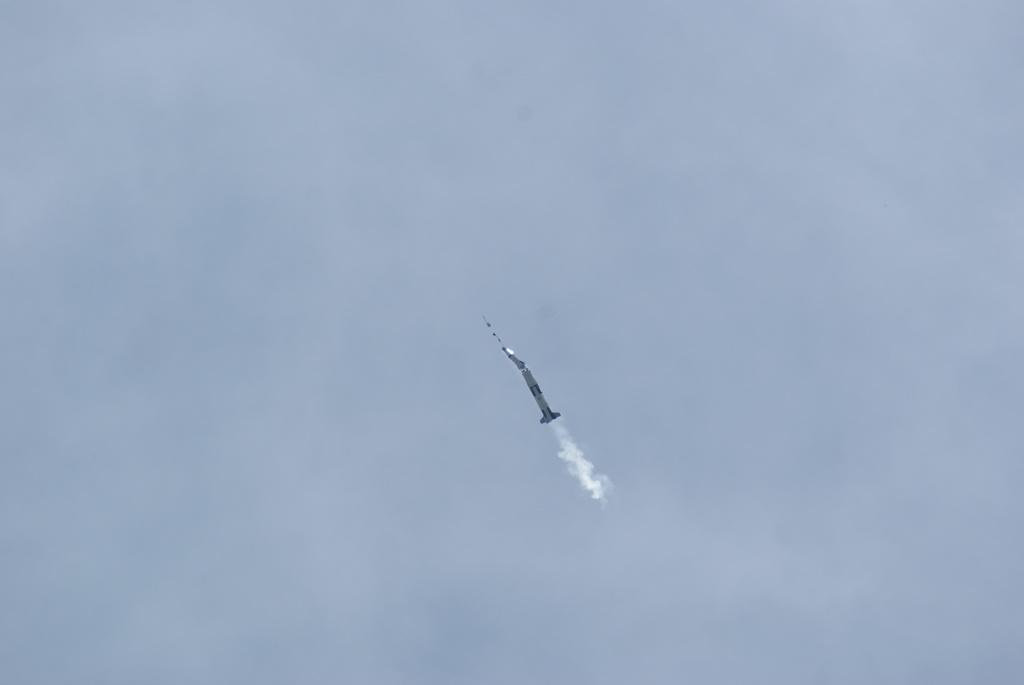What is the main subject of the image? The main subject of the image is a rocket. Where is the rocket located in the image? The rocket is in the sky. What can be observed as a result of the rocket's movement in the image? The rocket is leaving a trail of smoke in the image. How many women are holding soap near the rocket in the image? There are no women or soap present in the image; it only features a rocket in the sky leaving a trail of smoke. 